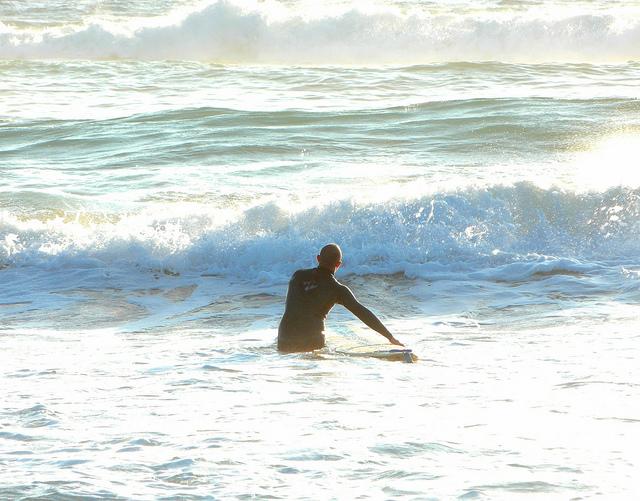Is this man going to surf?
Concise answer only. Yes. Why are the waves so rough?
Keep it brief. Wind. Is the surfer old?
Write a very short answer. Yes. 